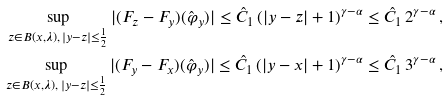<formula> <loc_0><loc_0><loc_500><loc_500>\sup _ { z \in B ( x , \lambda ) , \, | y - z | \leq \frac { 1 } { 2 } } | ( F _ { z } - F _ { y } ) ( \hat { \varphi } _ { y } ) | \leq \hat { C } _ { 1 } \, ( | y - z | + 1 ) ^ { \gamma - \alpha } \leq \hat { C } _ { 1 } \, 2 ^ { \gamma - \alpha } \, , \\ \sup _ { z \in B ( x , \lambda ) , \, | y - z | \leq \frac { 1 } { 2 } } | ( F _ { y } - F _ { x } ) ( \hat { \varphi } _ { y } ) | \leq \hat { C } _ { 1 } \, ( | y - x | + 1 ) ^ { \gamma - \alpha } \leq \hat { C } _ { 1 } \, 3 ^ { \gamma - \alpha } \, ,</formula> 